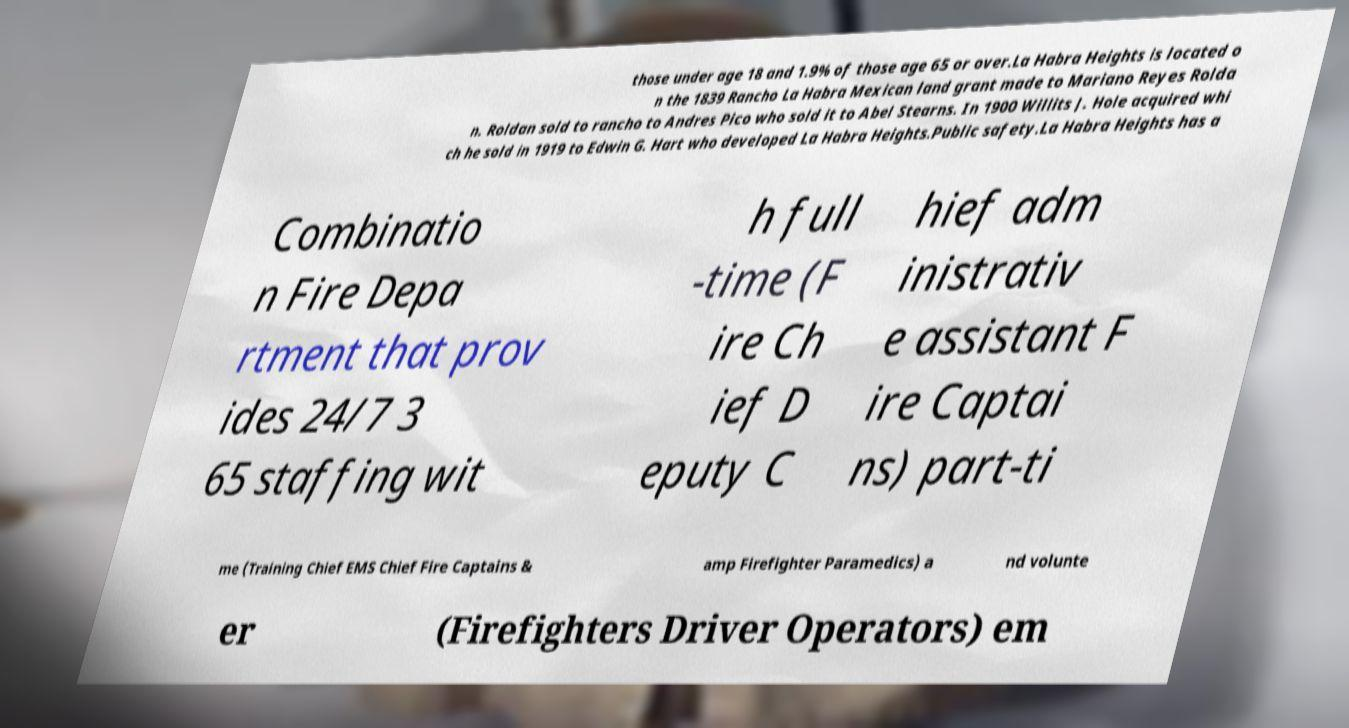Could you assist in decoding the text presented in this image and type it out clearly? those under age 18 and 1.9% of those age 65 or over.La Habra Heights is located o n the 1839 Rancho La Habra Mexican land grant made to Mariano Reyes Rolda n. Roldan sold to rancho to Andres Pico who sold it to Abel Stearns. In 1900 Willits J. Hole acquired whi ch he sold in 1919 to Edwin G. Hart who developed La Habra Heights.Public safety.La Habra Heights has a Combinatio n Fire Depa rtment that prov ides 24/7 3 65 staffing wit h full -time (F ire Ch ief D eputy C hief adm inistrativ e assistant F ire Captai ns) part-ti me (Training Chief EMS Chief Fire Captains & amp Firefighter Paramedics) a nd volunte er (Firefighters Driver Operators) em 